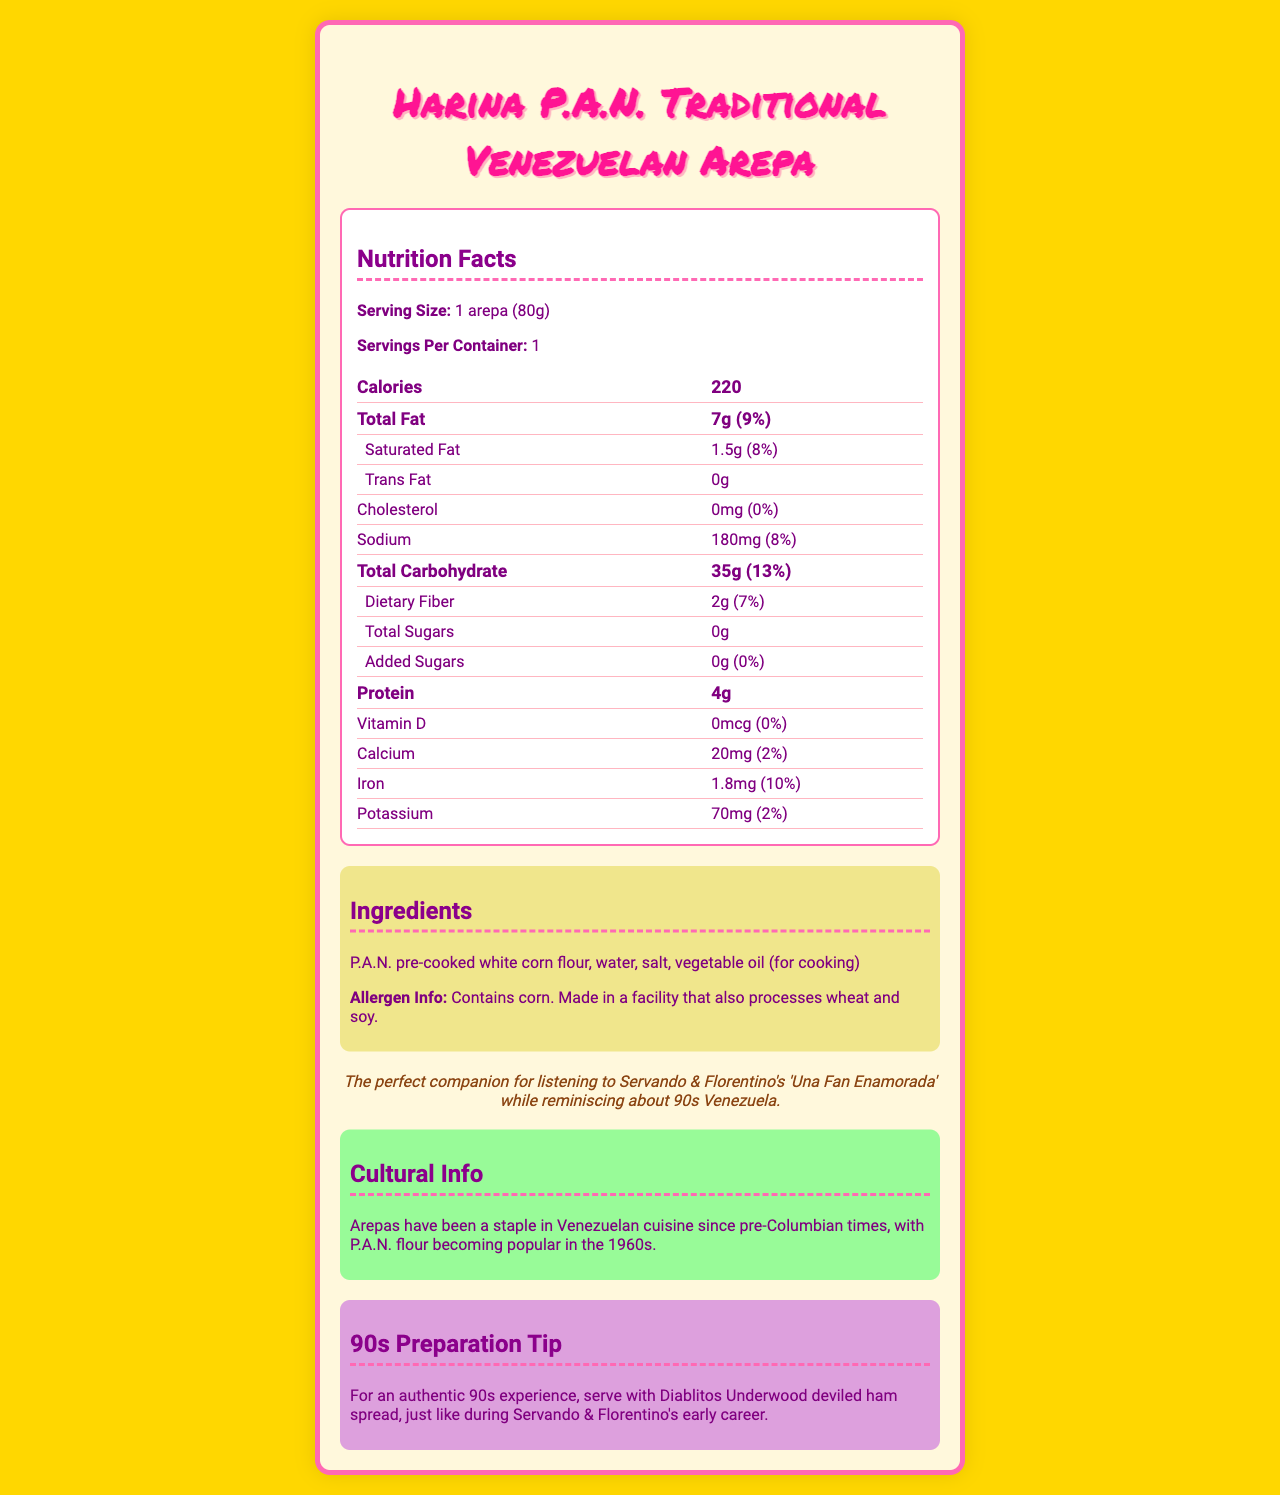what is the serving size? The serving size is clearly stated at the beginning of the Nutrition Facts section.
Answer: 1 arepa (80g) how many calories are there per serving? The calories per serving are listed at the top of the Nutrition Facts section.
Answer: 220 what is the amount of saturated fat per serving? This amount is listed under the Total Fat category in the Nutrition Facts.
Answer: 1.5g what are the main ingredients of the arepa? The ingredients are listed in the Ingredients section.
Answer: P.A.N. pre-cooked white corn flour, water, salt, vegetable oil (for cooking) how much protein is in one arepa? The amount of protein is specified in the Nutrition Facts section.
Answer: 4g what is the calcium content per serving? The calcium content is listed under the vitamins and minerals section of the Nutrition Facts.
Answer: 20mg how much sodium does a serving contain? The sodium content is displayed in the Nutrition Facts section.
Answer: 180mg which organization processes the flour used in this arepa? The brand name "Harina P.A.N." is given at the top of the document.
Answer: Harina P.A.N. does one serving of arepa contain any trans fat? The document specifies that the trans fat content is 0g.
Answer: No how many grams of dietary fiber are in a serving? A. 1g B. 2g C. 3g D. 4g The Nutrition Facts section lists 2g of dietary fiber per serving.
Answer: B what is the percentage daily value of iron per serving? 1. 5% 2. 10% 3. 15% 4. 20% The figure of 10% daily value for iron is shown in the Nutrition Facts.
Answer: 2 how much potassium is in a serving? i. 20mg ii. 50mg iii. 70mg iv. 100mg The potassium content listed is 70mg.
Answer: iii is there added sugar in the arepa? The Nutrition Facts state that added sugars amount to 0g.
Answer: No what is the cultural significance of arepas in Venezuela? This information is provided in the Cultural Info section of the document.
Answer: Arepas have been a staple in Venezuelan cuisine since pre-Columbian times, with P.A.N. flour becoming popular in the 1960s. can the exact cooking method for the arepa be determined from the document? The document provides ingredients and a nostalgic note, but does not give a detailed cooking method.
Answer: Not enough information describe the main contents of the document. The document includes a thorough breakdown of nutritional facts, ingredient information, cultural context, and a nostalgic touch reflecting the 90s era in Venezuela.
Answer: The document provides the nutritional information for a traditional Venezuelan arepa made with P.A.N. flour. It details the serving size, calories, fat content, cholesterol, sodium, carbohydrates, protein, and various vitamins and minerals. Additionally, it lists ingredients, potential allergens, cultural information, and a nostalgic note. 